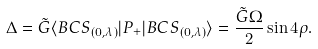Convert formula to latex. <formula><loc_0><loc_0><loc_500><loc_500>\Delta = \tilde { G } \langle B C S _ { ( 0 , \lambda ) } | P _ { + } | B C S _ { ( 0 , \lambda ) } \rangle = \frac { \tilde { G } \Omega } { 2 } \sin 4 \rho .</formula> 